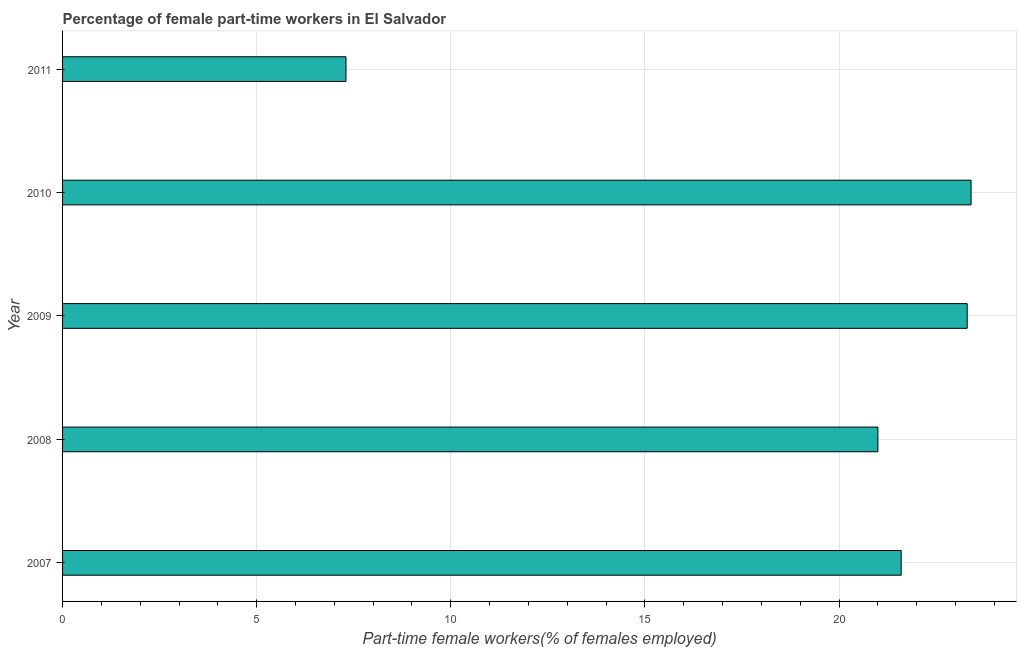What is the title of the graph?
Your answer should be very brief. Percentage of female part-time workers in El Salvador. What is the label or title of the X-axis?
Offer a very short reply. Part-time female workers(% of females employed). What is the label or title of the Y-axis?
Keep it short and to the point. Year. What is the percentage of part-time female workers in 2007?
Your answer should be compact. 21.6. Across all years, what is the maximum percentage of part-time female workers?
Give a very brief answer. 23.4. Across all years, what is the minimum percentage of part-time female workers?
Give a very brief answer. 7.3. In which year was the percentage of part-time female workers minimum?
Your answer should be compact. 2011. What is the sum of the percentage of part-time female workers?
Make the answer very short. 96.6. What is the average percentage of part-time female workers per year?
Keep it short and to the point. 19.32. What is the median percentage of part-time female workers?
Your answer should be compact. 21.6. In how many years, is the percentage of part-time female workers greater than 23 %?
Ensure brevity in your answer.  2. Do a majority of the years between 2008 and 2007 (inclusive) have percentage of part-time female workers greater than 11 %?
Your response must be concise. No. What is the ratio of the percentage of part-time female workers in 2009 to that in 2011?
Give a very brief answer. 3.19. Is the sum of the percentage of part-time female workers in 2007 and 2010 greater than the maximum percentage of part-time female workers across all years?
Make the answer very short. Yes. What is the difference between two consecutive major ticks on the X-axis?
Provide a succinct answer. 5. What is the Part-time female workers(% of females employed) in 2007?
Offer a very short reply. 21.6. What is the Part-time female workers(% of females employed) of 2008?
Offer a very short reply. 21. What is the Part-time female workers(% of females employed) in 2009?
Provide a short and direct response. 23.3. What is the Part-time female workers(% of females employed) of 2010?
Offer a very short reply. 23.4. What is the Part-time female workers(% of females employed) in 2011?
Make the answer very short. 7.3. What is the difference between the Part-time female workers(% of females employed) in 2007 and 2008?
Give a very brief answer. 0.6. What is the difference between the Part-time female workers(% of females employed) in 2007 and 2010?
Your answer should be compact. -1.8. What is the difference between the Part-time female workers(% of females employed) in 2007 and 2011?
Offer a terse response. 14.3. What is the difference between the Part-time female workers(% of females employed) in 2008 and 2010?
Offer a very short reply. -2.4. What is the difference between the Part-time female workers(% of females employed) in 2009 and 2010?
Provide a succinct answer. -0.1. What is the difference between the Part-time female workers(% of females employed) in 2009 and 2011?
Your answer should be compact. 16. What is the ratio of the Part-time female workers(% of females employed) in 2007 to that in 2009?
Ensure brevity in your answer.  0.93. What is the ratio of the Part-time female workers(% of females employed) in 2007 to that in 2010?
Your answer should be compact. 0.92. What is the ratio of the Part-time female workers(% of females employed) in 2007 to that in 2011?
Offer a very short reply. 2.96. What is the ratio of the Part-time female workers(% of females employed) in 2008 to that in 2009?
Offer a terse response. 0.9. What is the ratio of the Part-time female workers(% of females employed) in 2008 to that in 2010?
Offer a very short reply. 0.9. What is the ratio of the Part-time female workers(% of females employed) in 2008 to that in 2011?
Offer a very short reply. 2.88. What is the ratio of the Part-time female workers(% of females employed) in 2009 to that in 2011?
Provide a short and direct response. 3.19. What is the ratio of the Part-time female workers(% of females employed) in 2010 to that in 2011?
Keep it short and to the point. 3.21. 